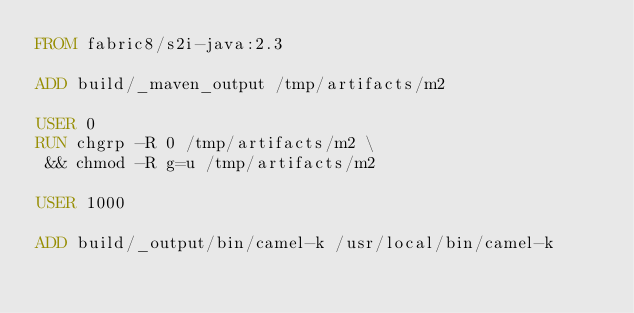<code> <loc_0><loc_0><loc_500><loc_500><_Dockerfile_>FROM fabric8/s2i-java:2.3

ADD build/_maven_output /tmp/artifacts/m2

USER 0
RUN chgrp -R 0 /tmp/artifacts/m2 \
 && chmod -R g=u /tmp/artifacts/m2

USER 1000

ADD build/_output/bin/camel-k /usr/local/bin/camel-k
</code> 